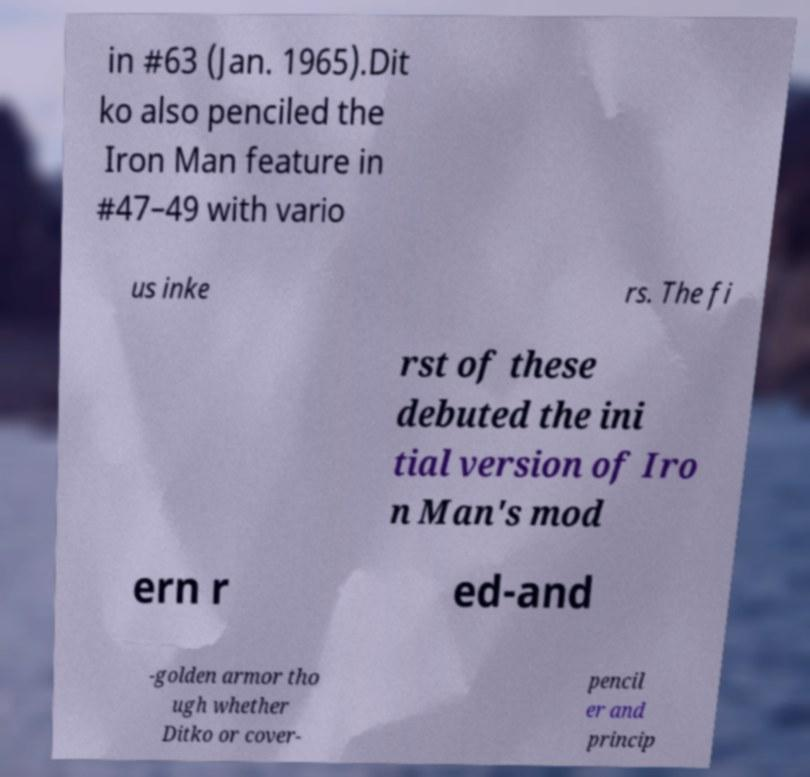For documentation purposes, I need the text within this image transcribed. Could you provide that? in #63 (Jan. 1965).Dit ko also penciled the Iron Man feature in #47–49 with vario us inke rs. The fi rst of these debuted the ini tial version of Iro n Man's mod ern r ed-and -golden armor tho ugh whether Ditko or cover- pencil er and princip 